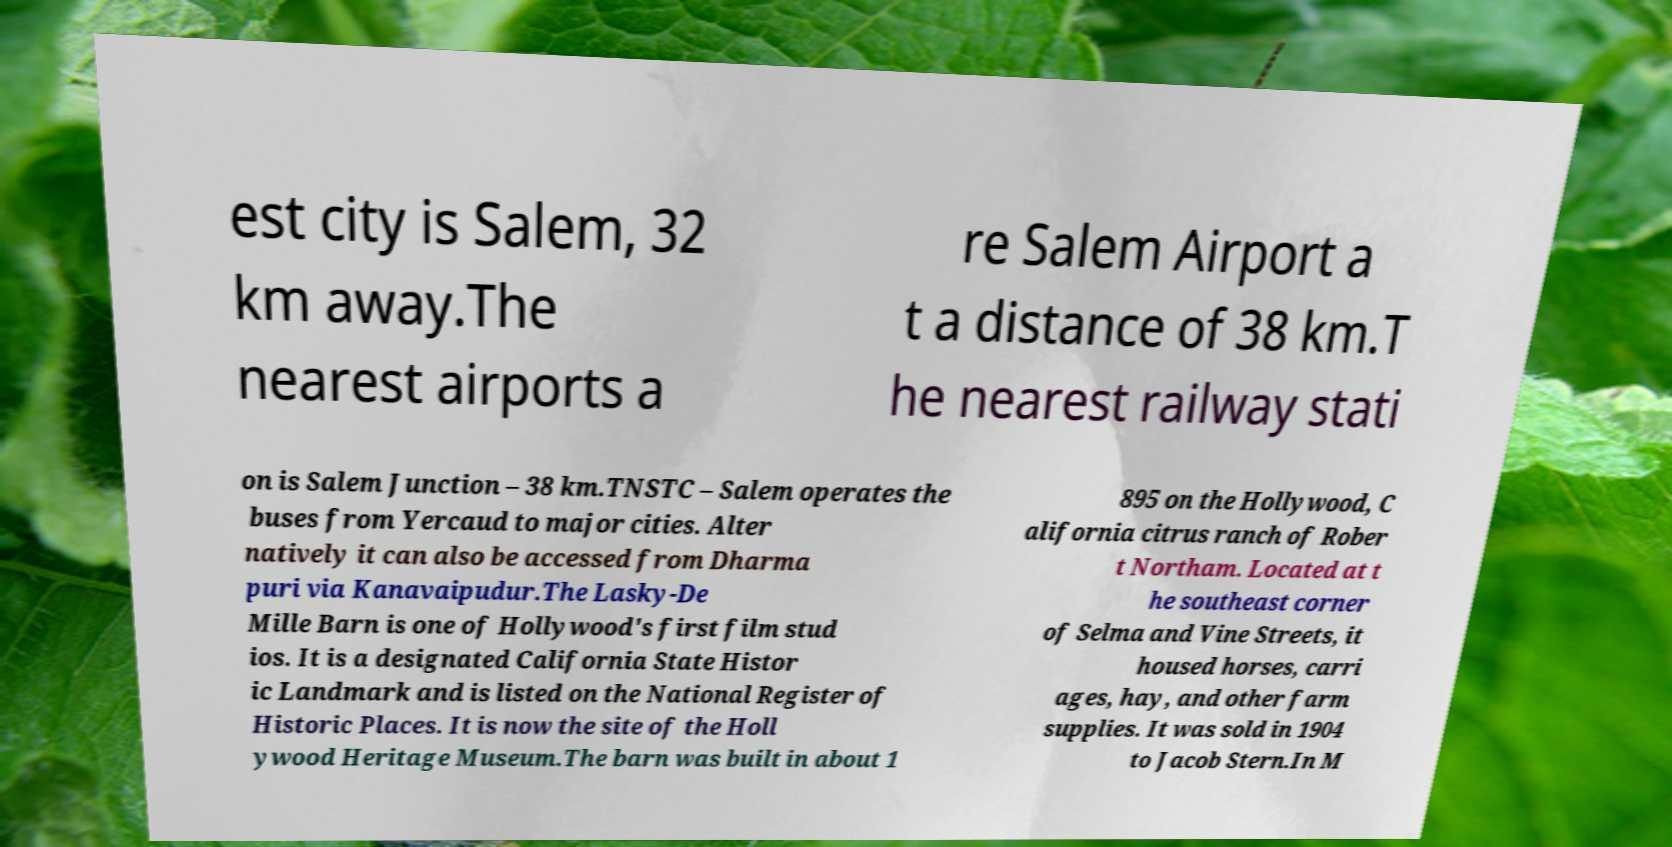Can you accurately transcribe the text from the provided image for me? est city is Salem, 32 km away.The nearest airports a re Salem Airport a t a distance of 38 km.T he nearest railway stati on is Salem Junction – 38 km.TNSTC – Salem operates the buses from Yercaud to major cities. Alter natively it can also be accessed from Dharma puri via Kanavaipudur.The Lasky-De Mille Barn is one of Hollywood's first film stud ios. It is a designated California State Histor ic Landmark and is listed on the National Register of Historic Places. It is now the site of the Holl ywood Heritage Museum.The barn was built in about 1 895 on the Hollywood, C alifornia citrus ranch of Rober t Northam. Located at t he southeast corner of Selma and Vine Streets, it housed horses, carri ages, hay, and other farm supplies. It was sold in 1904 to Jacob Stern.In M 